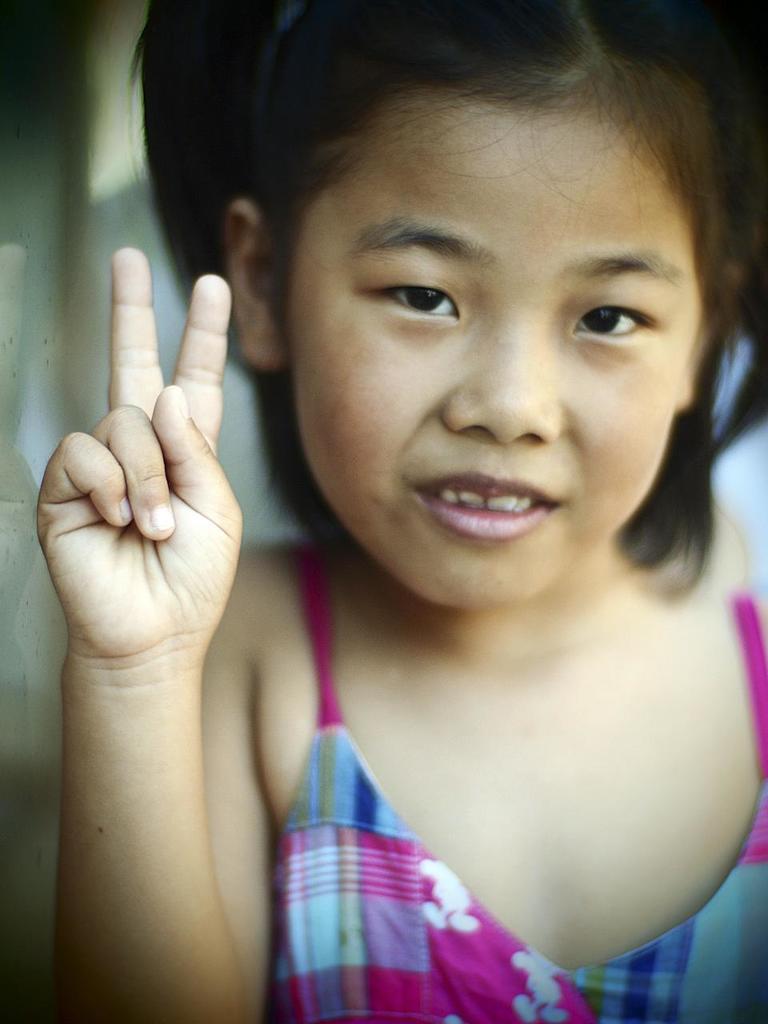In one or two sentences, can you explain what this image depicts? In this picture we can see a girl smiling and in the background it is blurry. 